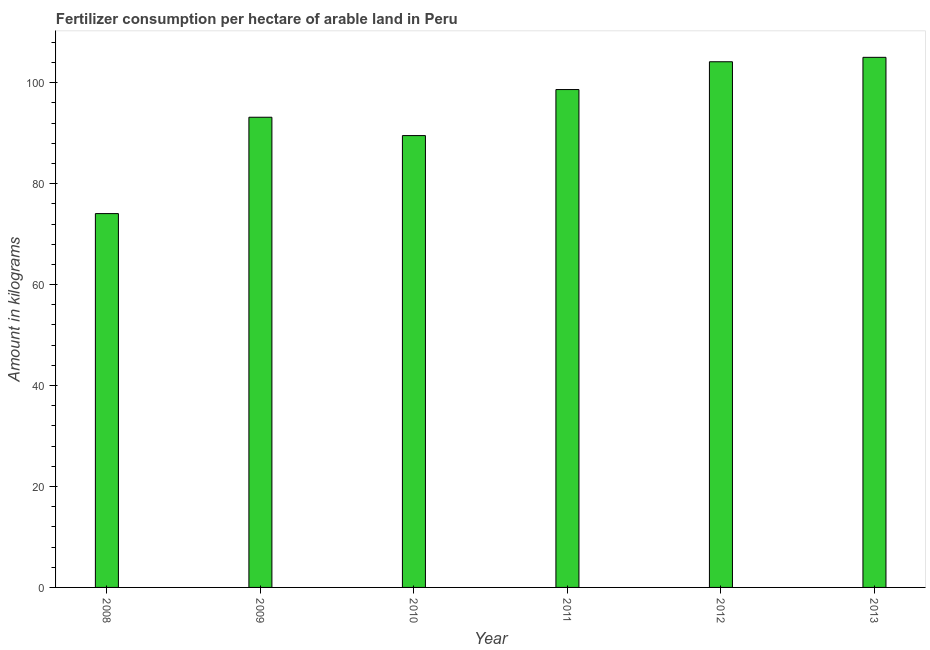What is the title of the graph?
Provide a succinct answer. Fertilizer consumption per hectare of arable land in Peru . What is the label or title of the Y-axis?
Offer a very short reply. Amount in kilograms. What is the amount of fertilizer consumption in 2012?
Keep it short and to the point. 104.15. Across all years, what is the maximum amount of fertilizer consumption?
Give a very brief answer. 105.03. Across all years, what is the minimum amount of fertilizer consumption?
Offer a very short reply. 74.07. In which year was the amount of fertilizer consumption maximum?
Provide a short and direct response. 2013. What is the sum of the amount of fertilizer consumption?
Your answer should be very brief. 564.56. What is the difference between the amount of fertilizer consumption in 2010 and 2011?
Make the answer very short. -9.12. What is the average amount of fertilizer consumption per year?
Your answer should be very brief. 94.09. What is the median amount of fertilizer consumption?
Provide a short and direct response. 95.9. In how many years, is the amount of fertilizer consumption greater than 88 kg?
Your answer should be very brief. 5. Do a majority of the years between 2011 and 2013 (inclusive) have amount of fertilizer consumption greater than 32 kg?
Your answer should be compact. Yes. What is the ratio of the amount of fertilizer consumption in 2009 to that in 2012?
Your answer should be very brief. 0.89. What is the difference between the highest and the second highest amount of fertilizer consumption?
Give a very brief answer. 0.88. What is the difference between the highest and the lowest amount of fertilizer consumption?
Your response must be concise. 30.96. In how many years, is the amount of fertilizer consumption greater than the average amount of fertilizer consumption taken over all years?
Your answer should be very brief. 3. How many bars are there?
Give a very brief answer. 6. How many years are there in the graph?
Make the answer very short. 6. Are the values on the major ticks of Y-axis written in scientific E-notation?
Offer a very short reply. No. What is the Amount in kilograms of 2008?
Offer a very short reply. 74.07. What is the Amount in kilograms in 2009?
Give a very brief answer. 93.16. What is the Amount in kilograms of 2010?
Your answer should be compact. 89.52. What is the Amount in kilograms of 2011?
Give a very brief answer. 98.64. What is the Amount in kilograms of 2012?
Provide a short and direct response. 104.15. What is the Amount in kilograms of 2013?
Your answer should be compact. 105.03. What is the difference between the Amount in kilograms in 2008 and 2009?
Give a very brief answer. -19.09. What is the difference between the Amount in kilograms in 2008 and 2010?
Offer a terse response. -15.46. What is the difference between the Amount in kilograms in 2008 and 2011?
Ensure brevity in your answer.  -24.58. What is the difference between the Amount in kilograms in 2008 and 2012?
Ensure brevity in your answer.  -30.09. What is the difference between the Amount in kilograms in 2008 and 2013?
Provide a short and direct response. -30.96. What is the difference between the Amount in kilograms in 2009 and 2010?
Your answer should be very brief. 3.64. What is the difference between the Amount in kilograms in 2009 and 2011?
Give a very brief answer. -5.48. What is the difference between the Amount in kilograms in 2009 and 2012?
Your answer should be compact. -10.99. What is the difference between the Amount in kilograms in 2009 and 2013?
Offer a very short reply. -11.87. What is the difference between the Amount in kilograms in 2010 and 2011?
Give a very brief answer. -9.12. What is the difference between the Amount in kilograms in 2010 and 2012?
Offer a very short reply. -14.63. What is the difference between the Amount in kilograms in 2010 and 2013?
Your response must be concise. -15.51. What is the difference between the Amount in kilograms in 2011 and 2012?
Give a very brief answer. -5.51. What is the difference between the Amount in kilograms in 2011 and 2013?
Give a very brief answer. -6.38. What is the difference between the Amount in kilograms in 2012 and 2013?
Keep it short and to the point. -0.88. What is the ratio of the Amount in kilograms in 2008 to that in 2009?
Your answer should be compact. 0.8. What is the ratio of the Amount in kilograms in 2008 to that in 2010?
Your answer should be very brief. 0.83. What is the ratio of the Amount in kilograms in 2008 to that in 2011?
Give a very brief answer. 0.75. What is the ratio of the Amount in kilograms in 2008 to that in 2012?
Keep it short and to the point. 0.71. What is the ratio of the Amount in kilograms in 2008 to that in 2013?
Your response must be concise. 0.7. What is the ratio of the Amount in kilograms in 2009 to that in 2010?
Your answer should be very brief. 1.04. What is the ratio of the Amount in kilograms in 2009 to that in 2011?
Keep it short and to the point. 0.94. What is the ratio of the Amount in kilograms in 2009 to that in 2012?
Your answer should be very brief. 0.89. What is the ratio of the Amount in kilograms in 2009 to that in 2013?
Make the answer very short. 0.89. What is the ratio of the Amount in kilograms in 2010 to that in 2011?
Provide a succinct answer. 0.91. What is the ratio of the Amount in kilograms in 2010 to that in 2012?
Give a very brief answer. 0.86. What is the ratio of the Amount in kilograms in 2010 to that in 2013?
Make the answer very short. 0.85. What is the ratio of the Amount in kilograms in 2011 to that in 2012?
Offer a terse response. 0.95. What is the ratio of the Amount in kilograms in 2011 to that in 2013?
Give a very brief answer. 0.94. What is the ratio of the Amount in kilograms in 2012 to that in 2013?
Provide a succinct answer. 0.99. 